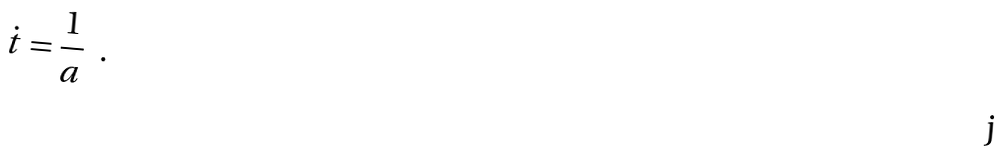Convert formula to latex. <formula><loc_0><loc_0><loc_500><loc_500>\dot { t } = { \frac { 1 } { a } } \ \ .</formula> 